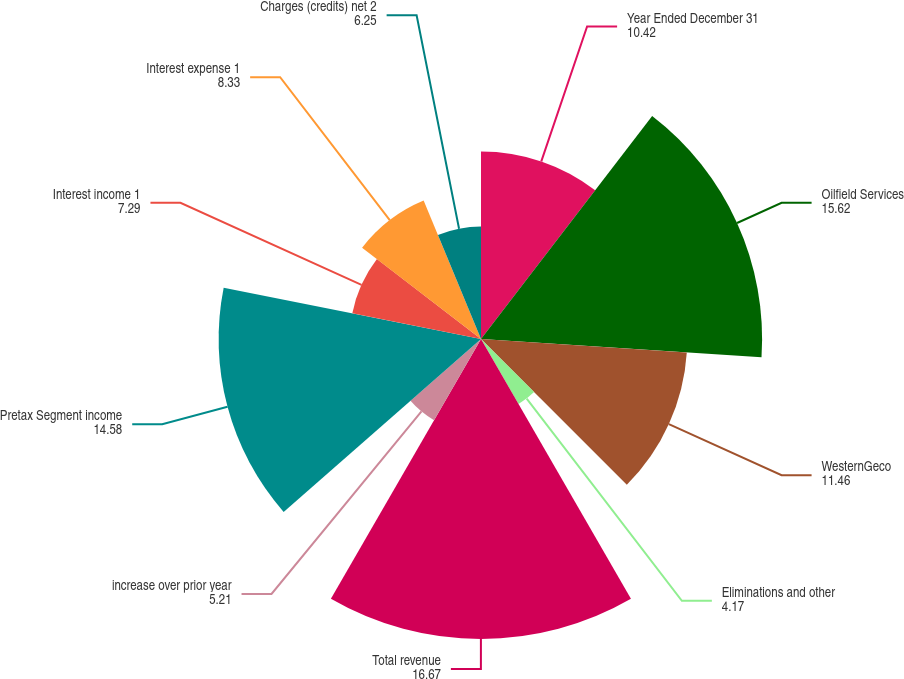<chart> <loc_0><loc_0><loc_500><loc_500><pie_chart><fcel>Year Ended December 31<fcel>Oilfield Services<fcel>WesternGeco<fcel>Eliminations and other<fcel>Total revenue<fcel>increase over prior year<fcel>Pretax Segment income<fcel>Interest income 1<fcel>Interest expense 1<fcel>Charges (credits) net 2<nl><fcel>10.42%<fcel>15.62%<fcel>11.46%<fcel>4.17%<fcel>16.67%<fcel>5.21%<fcel>14.58%<fcel>7.29%<fcel>8.33%<fcel>6.25%<nl></chart> 